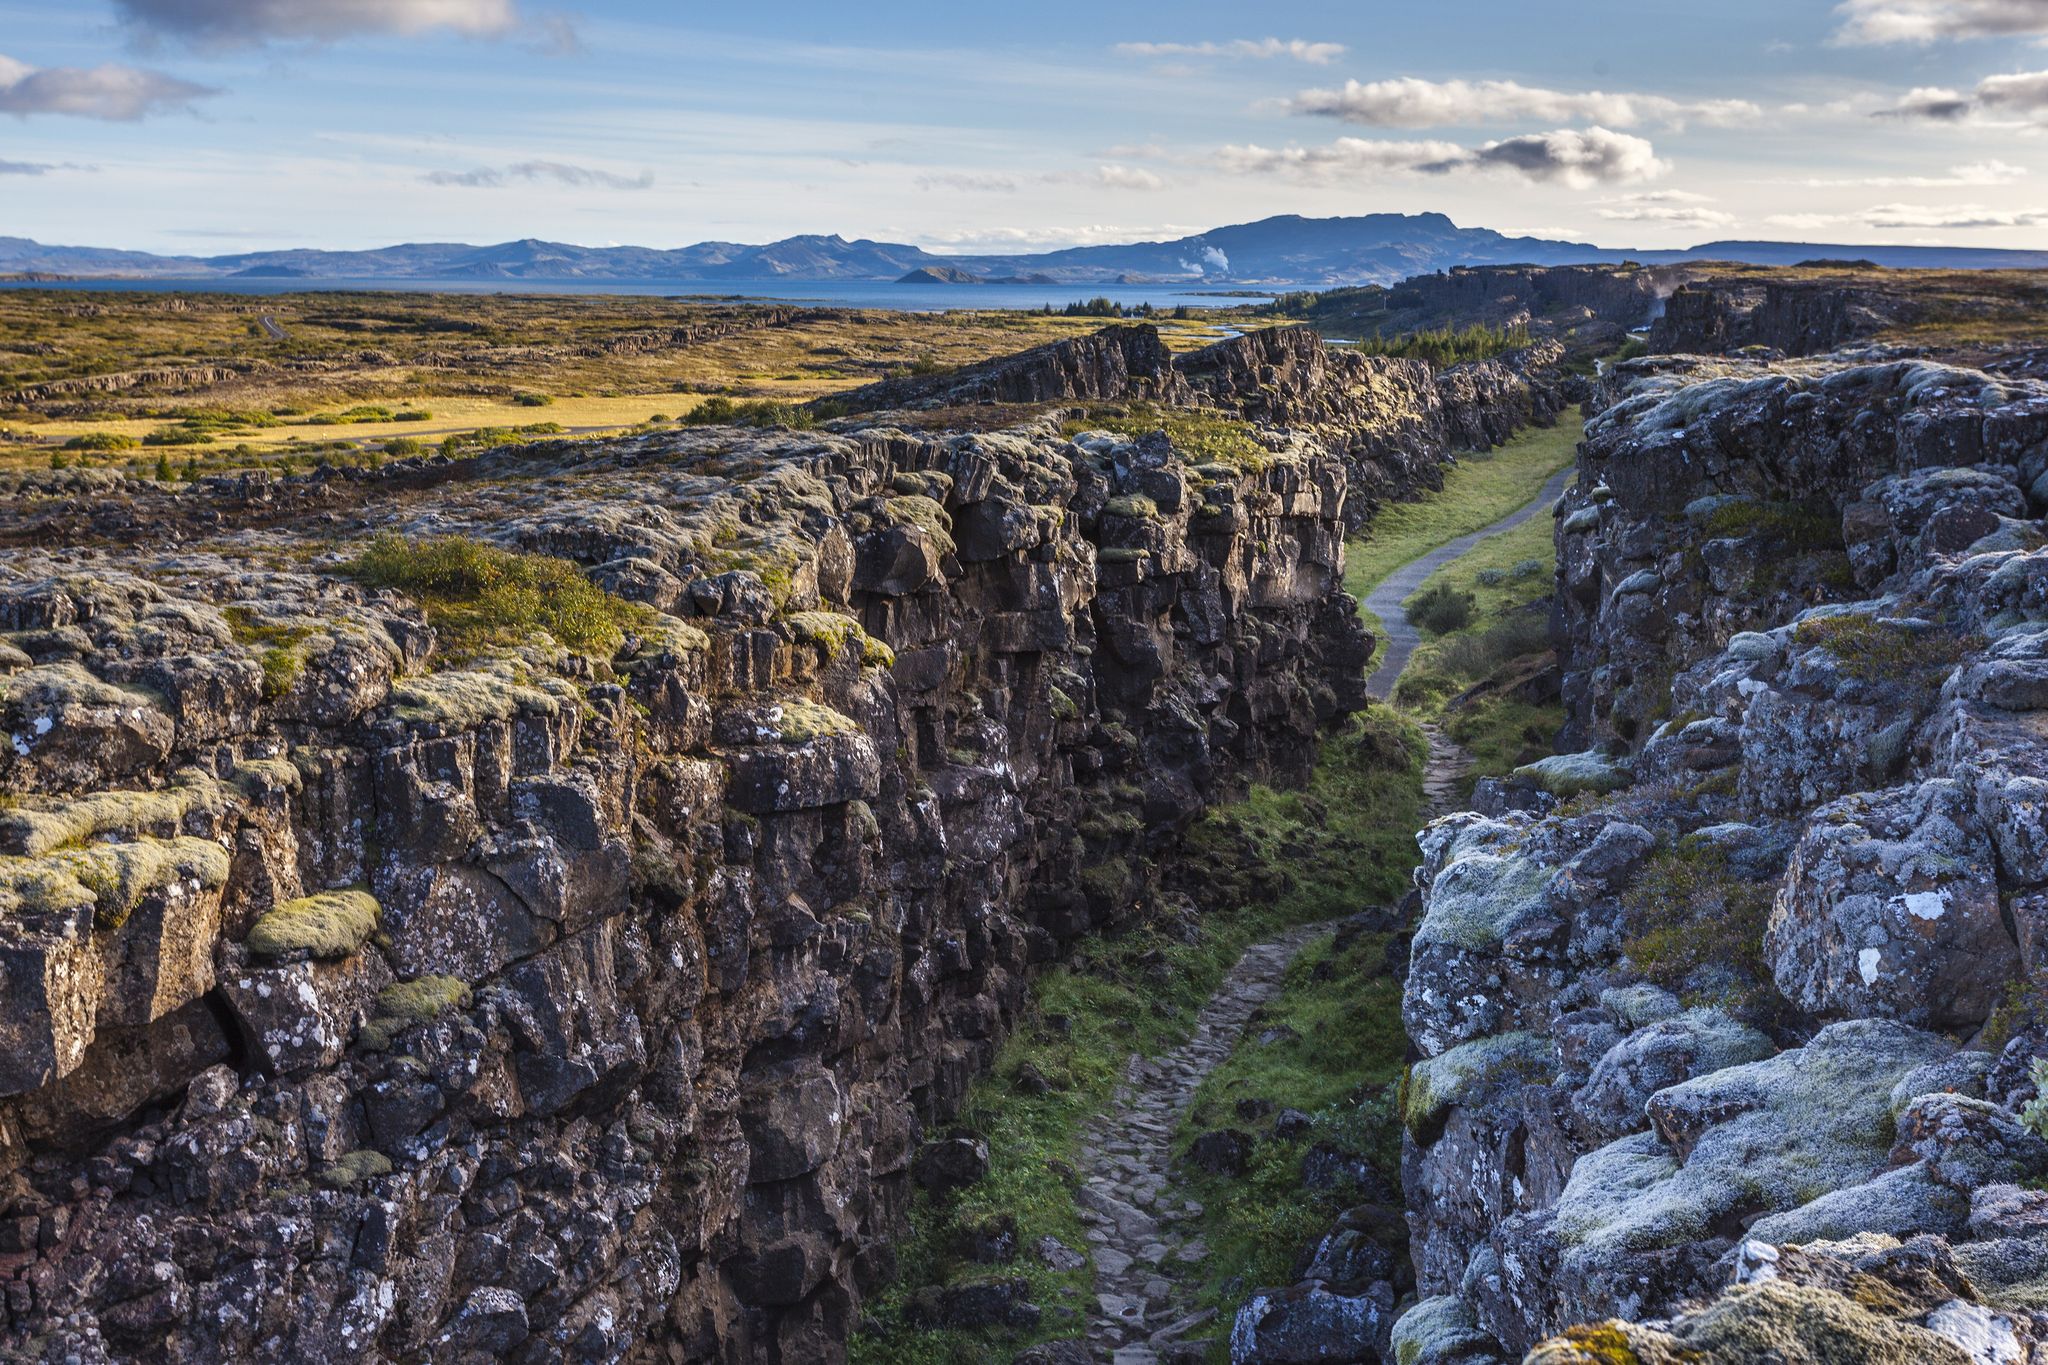Describe a day spent at Þingvellir National Park during the summer. A day spent at Þingvellir National Park during the summer is a magical experience. The long hours of daylight allow for extended exploration of the park's wonders. Start the day with a hike along the Almannagjá fault line, marveling at the geological interplay between the tectonic plates. Afterward, enjoy a leisurely picnic by the shores of Lake Þingvallavatn, where the crystal-clear waters reflect the blue sky and surrounding mountains. As the day progresses, take a guided tour to learn about the historical significance of the Alþingi. The evening can be spent watching the sun dip slowly, casting golden hues over the landscape, and if you're lucky, you might catch the ethereal glow of the midnight sun. 